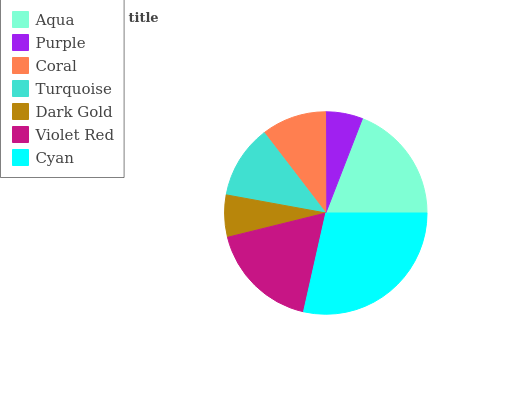Is Purple the minimum?
Answer yes or no. Yes. Is Cyan the maximum?
Answer yes or no. Yes. Is Coral the minimum?
Answer yes or no. No. Is Coral the maximum?
Answer yes or no. No. Is Coral greater than Purple?
Answer yes or no. Yes. Is Purple less than Coral?
Answer yes or no. Yes. Is Purple greater than Coral?
Answer yes or no. No. Is Coral less than Purple?
Answer yes or no. No. Is Turquoise the high median?
Answer yes or no. Yes. Is Turquoise the low median?
Answer yes or no. Yes. Is Dark Gold the high median?
Answer yes or no. No. Is Dark Gold the low median?
Answer yes or no. No. 